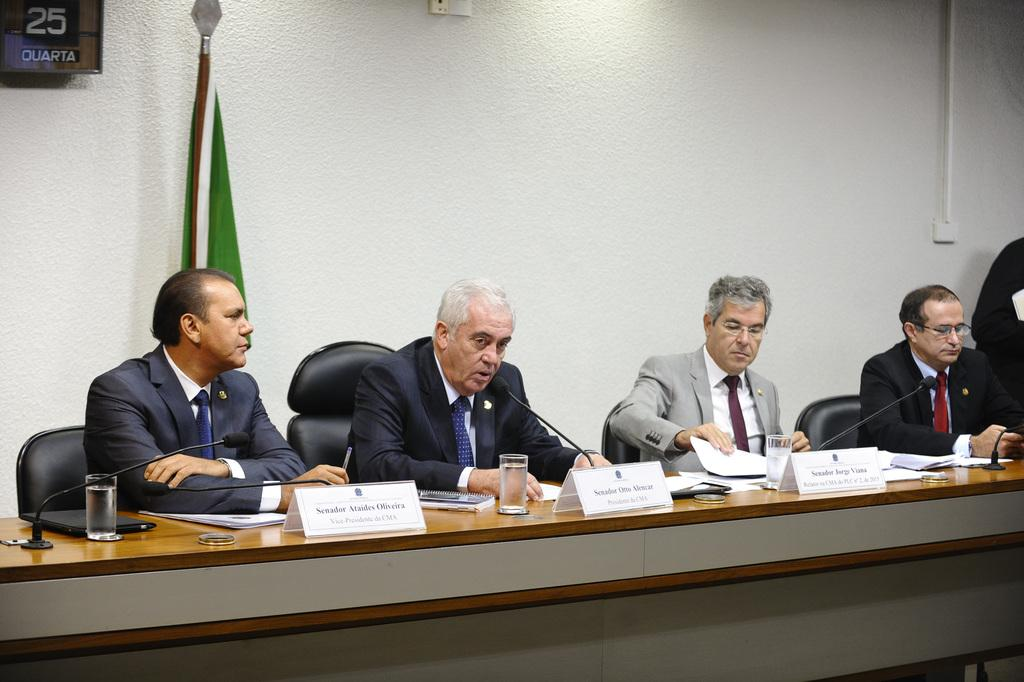What are the people in the image doing? There is a group of people sitting on chairs in the image. What is in front of the group? There is a table in front of the group. What can be seen on the table? There is a glass and a microphone on the table. What is at the back of the group? There is a wall at the back of the group. What is the additional element in the image? There is a flag in the image. What type of cracker is being passed around the table in the image? There is no cracker present in the image; it only shows a group of people sitting on chairs, a table, a glass, a microphone, a wall, and a flag. What color is the journey depicted in the image? The image does not depict a journey, and therefore, there is no color associated with it. 